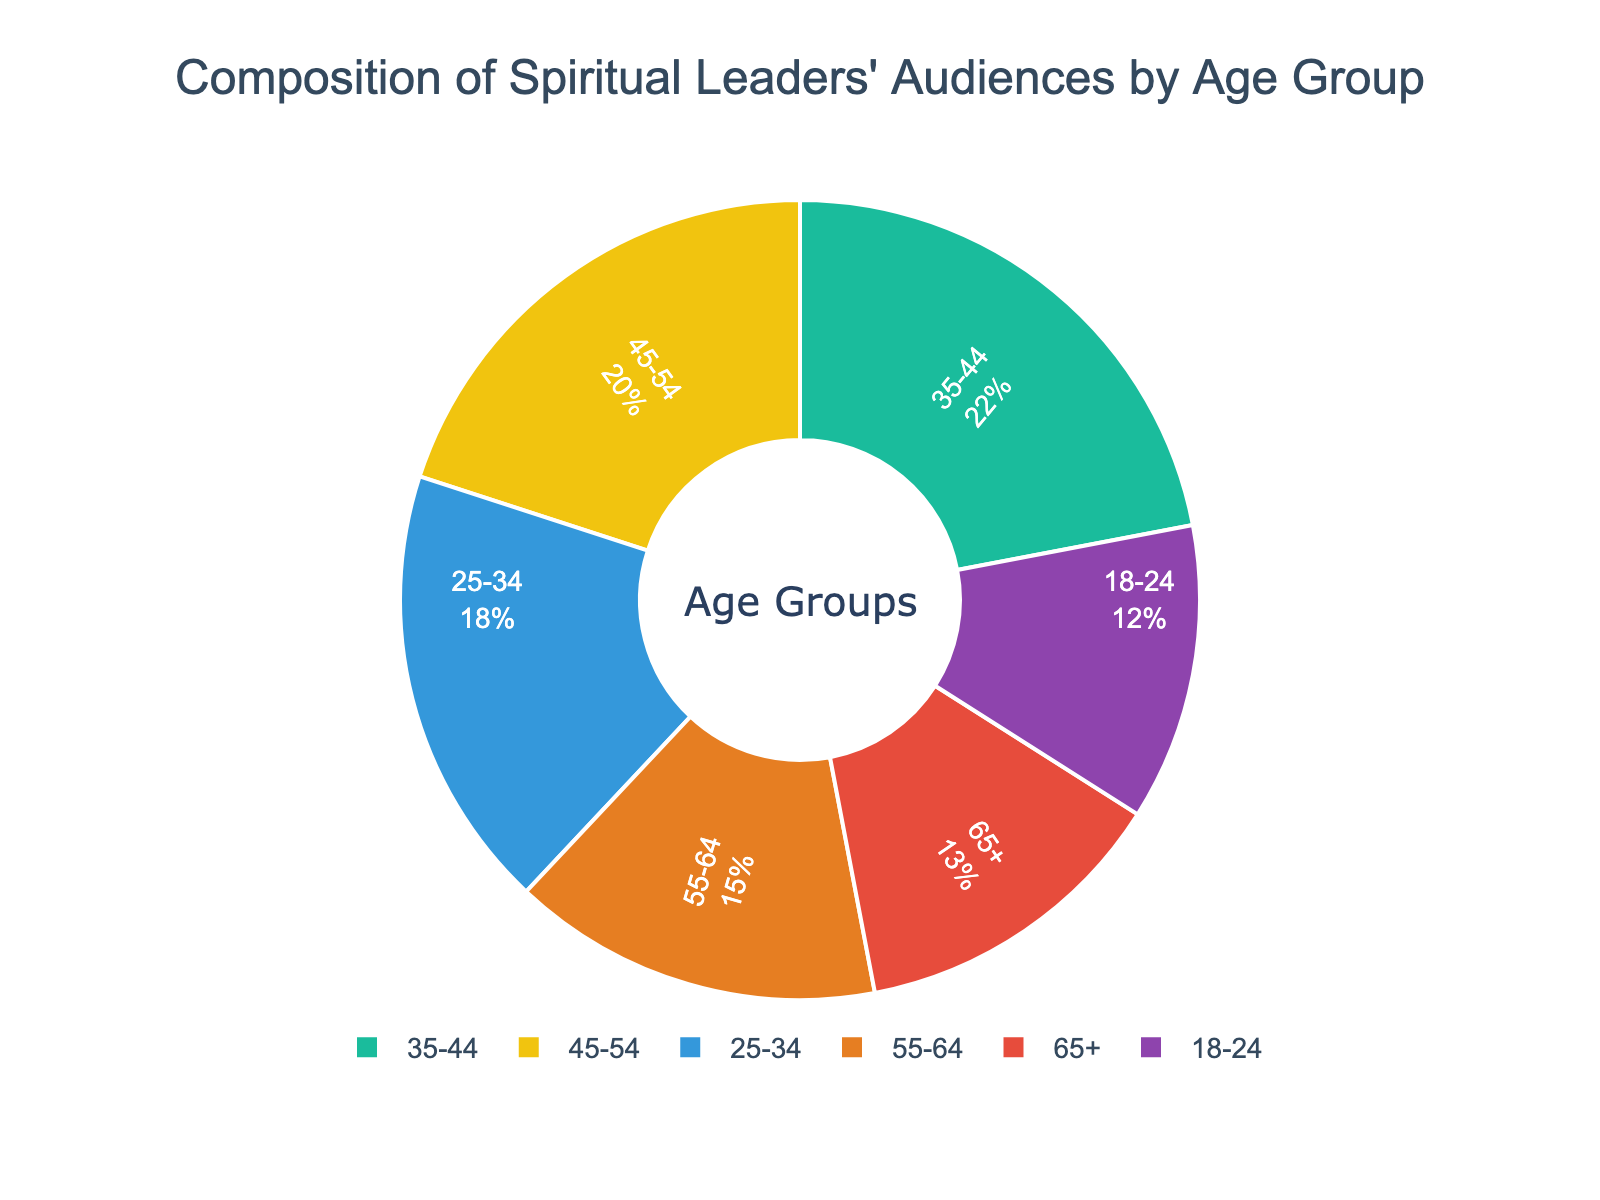What percentage of the audience is aged 35-44? The pie chart provides the percentage values directly. Look for the segment labeled 35-44.
Answer: 22% Which age group has the largest representation? Identify the segment in the pie chart that has the largest percentage value assigned.
Answer: 35-44 What is the combined percentage of the age groups 25-34 and 55-64? Sum the values of the age groups 25-34 and 55-64 shown in the chart. 18% + 15% = 33%
Answer: 33% Is the proportion of the 45-54 age group greater than that of the 65+ age group? Compare the percentage values for the 45-54 and 65+ age groups in the chart. 20% vs. 13%
Answer: Yes Between the 18-24 and 65+ age groups, which has a larger audience share? Compare the percentage values for the 18-24 and 65+ age groups in the chart. 12% vs. 13%
Answer: 65+ By how much does the audience percentage of the 35-44 age group exceed that of the 18-24 age group? Subtract the value of the 18-24 age group from the 35-44 age group. 22% - 12% = 10%
Answer: 10% What is the median age group percentage? List the percentages in ascending order: 12%, 13%, 15%, 18%, 20%, 22%. The median is the average of the middle values (18% and 20%). (18% + 20%) / 2 = 19%
Answer: 19% Which segment of the pie chart has a purple color? The data indicates that specific colors are used for each age group. The first color in the provided palette (purple) corresponds to the first age group (18-24).
Answer: 18-24 Is the 25-34 age group larger or smaller than the 55-64 age group? Compare the percentage values for the 25-34 and 55-64 age groups in the chart. 18% vs. 15%
Answer: Larger 